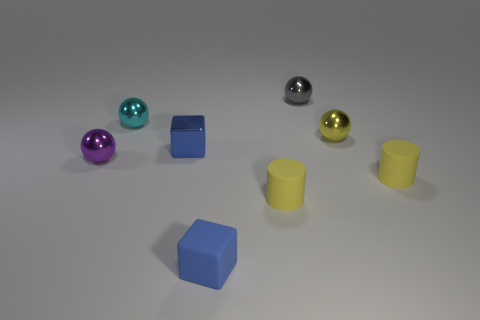How many objects are small brown spheres or small metal objects that are behind the small blue metallic block?
Make the answer very short. 3. What shape is the blue shiny object?
Your answer should be compact. Cube. What shape is the small yellow thing that is in front of the small cylinder that is right of the gray object?
Offer a very short reply. Cylinder. There is a tiny object that is the same color as the tiny metallic cube; what material is it?
Provide a succinct answer. Rubber. There is a tiny block that is made of the same material as the small cyan sphere; what is its color?
Your response must be concise. Blue. Is there any other thing that has the same size as the blue metal object?
Make the answer very short. Yes. Is the color of the small block in front of the purple object the same as the small metal sphere left of the cyan shiny ball?
Your answer should be compact. No. Are there more yellow spheres behind the gray object than metal things right of the blue rubber thing?
Your answer should be very brief. No. There is a small rubber object that is the same shape as the tiny blue metallic object; what is its color?
Ensure brevity in your answer.  Blue. Is there any other thing that is the same shape as the gray metallic thing?
Your answer should be very brief. Yes. 